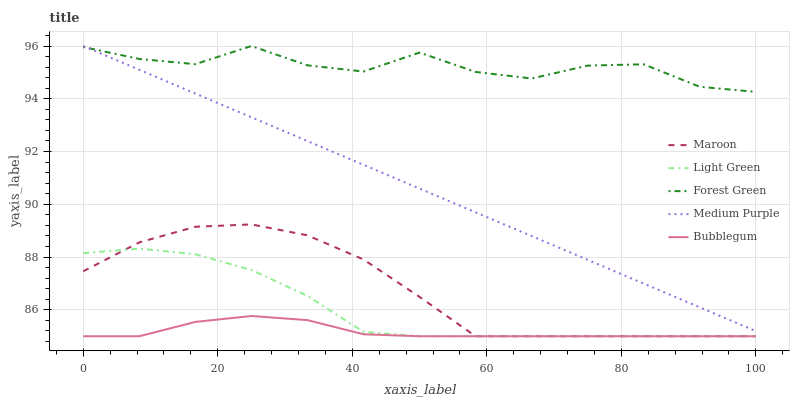Does Bubblegum have the minimum area under the curve?
Answer yes or no. Yes. Does Forest Green have the maximum area under the curve?
Answer yes or no. Yes. Does Forest Green have the minimum area under the curve?
Answer yes or no. No. Does Bubblegum have the maximum area under the curve?
Answer yes or no. No. Is Medium Purple the smoothest?
Answer yes or no. Yes. Is Forest Green the roughest?
Answer yes or no. Yes. Is Bubblegum the smoothest?
Answer yes or no. No. Is Bubblegum the roughest?
Answer yes or no. No. Does Bubblegum have the lowest value?
Answer yes or no. Yes. Does Forest Green have the lowest value?
Answer yes or no. No. Does Forest Green have the highest value?
Answer yes or no. Yes. Does Bubblegum have the highest value?
Answer yes or no. No. Is Bubblegum less than Forest Green?
Answer yes or no. Yes. Is Medium Purple greater than Bubblegum?
Answer yes or no. Yes. Does Maroon intersect Light Green?
Answer yes or no. Yes. Is Maroon less than Light Green?
Answer yes or no. No. Is Maroon greater than Light Green?
Answer yes or no. No. Does Bubblegum intersect Forest Green?
Answer yes or no. No. 